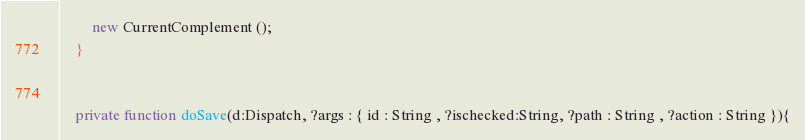<code> <loc_0><loc_0><loc_500><loc_500><_Haxe_>		new CurrentComplement ();
	}


	private function doSave(d:Dispatch, ?args : { id : String , ?ischecked:String, ?path : String , ?action : String }){</code> 